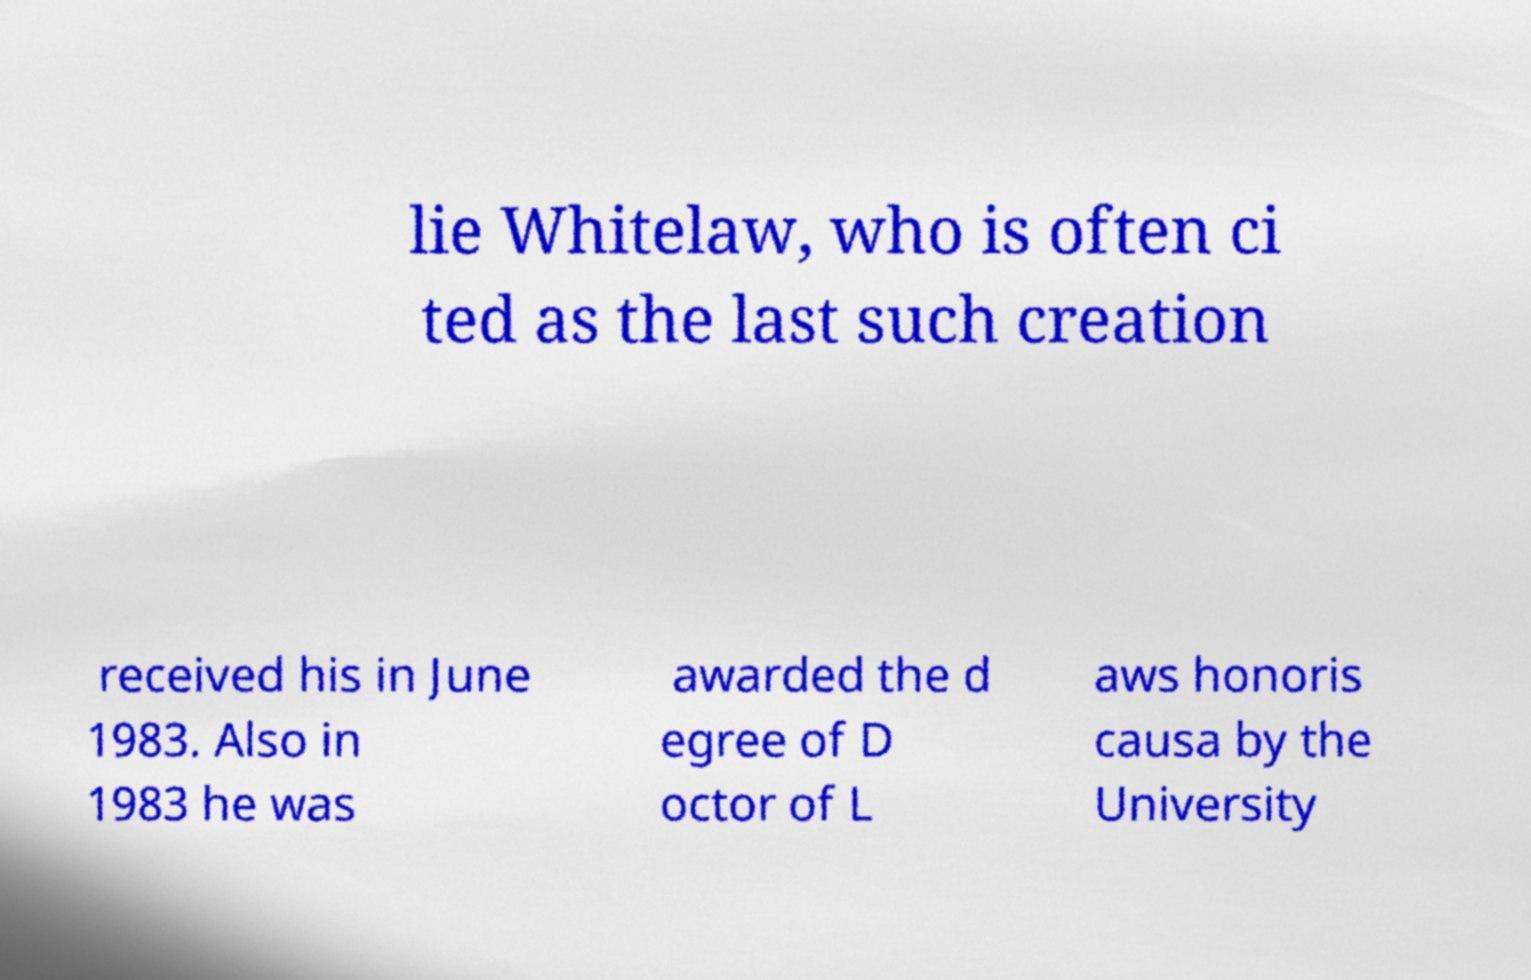Could you extract and type out the text from this image? lie Whitelaw, who is often ci ted as the last such creation received his in June 1983. Also in 1983 he was awarded the d egree of D octor of L aws honoris causa by the University 